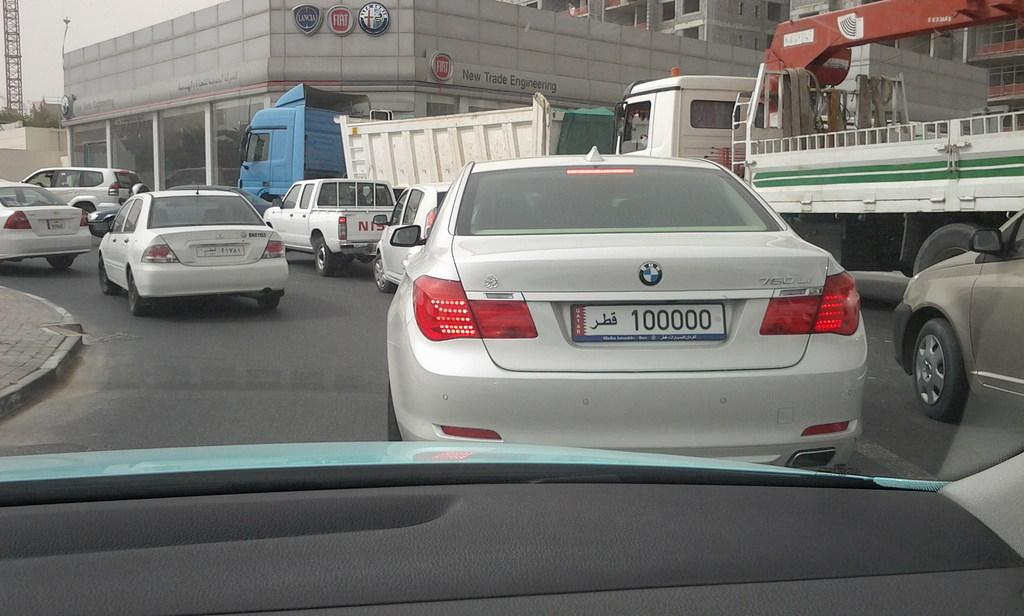<image>
Create a compact narrative representing the image presented. A BMW in traffic with a liscence tag that says 100000. 